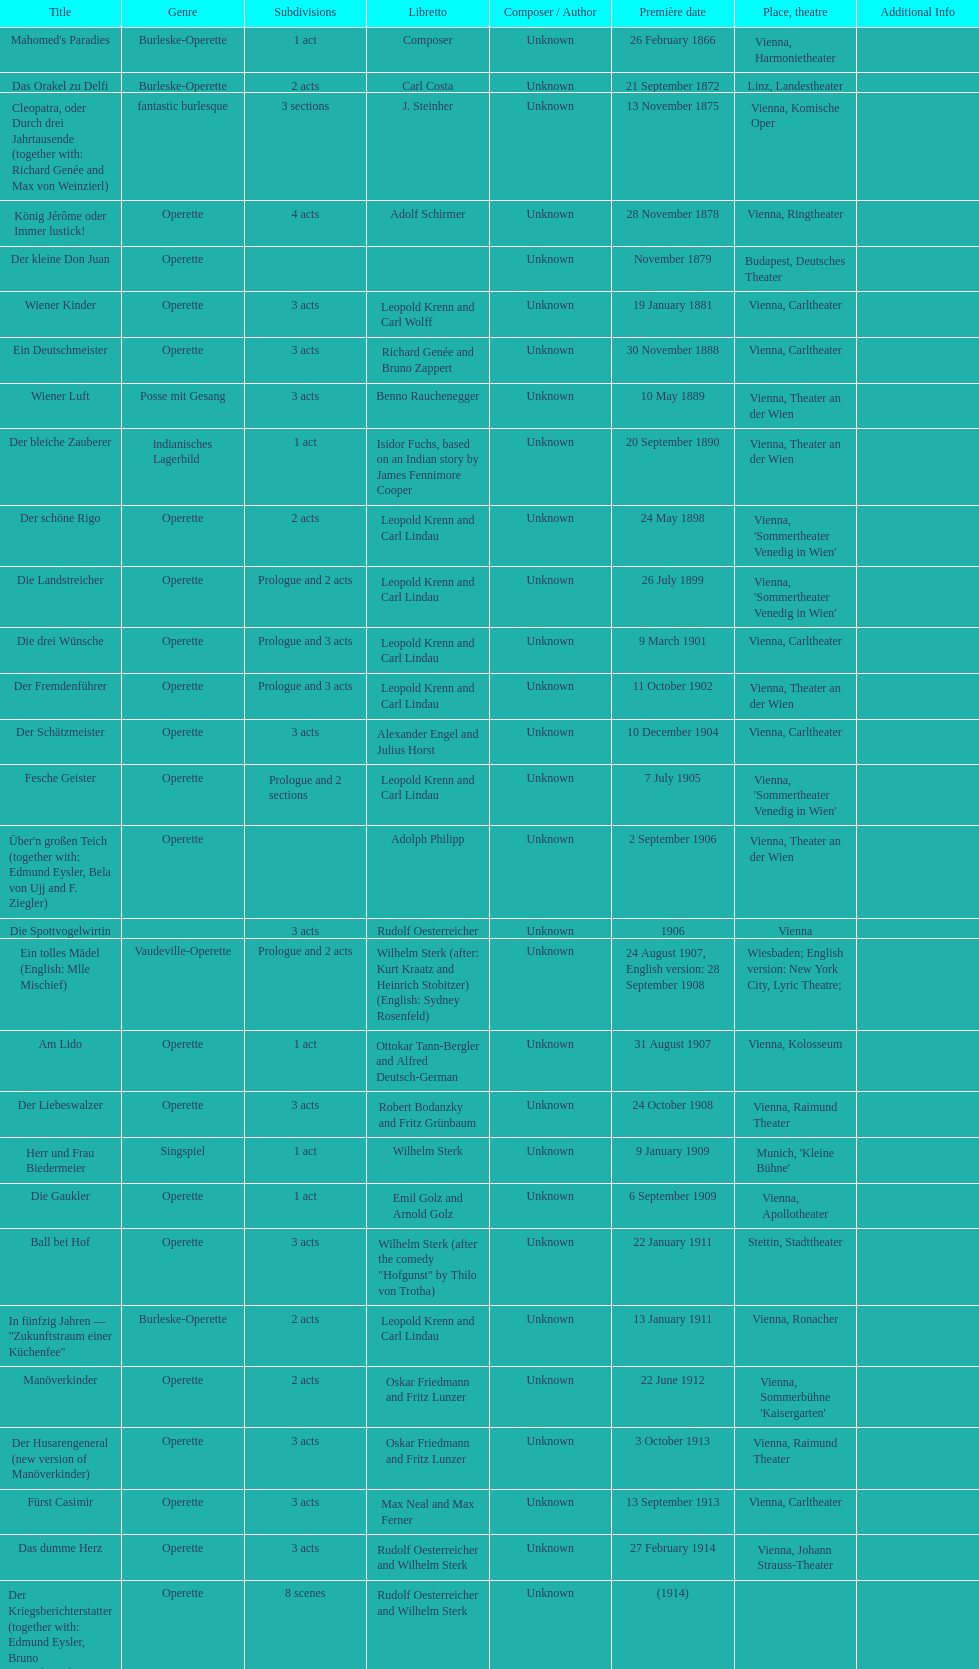Which year did he release his last operetta? 1930. 